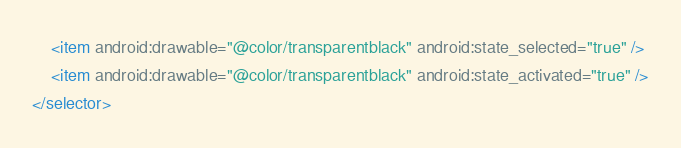Convert code to text. <code><loc_0><loc_0><loc_500><loc_500><_XML_>    <item android:drawable="@color/transparentblack" android:state_selected="true" />
    <item android:drawable="@color/transparentblack" android:state_activated="true" />
</selector></code> 